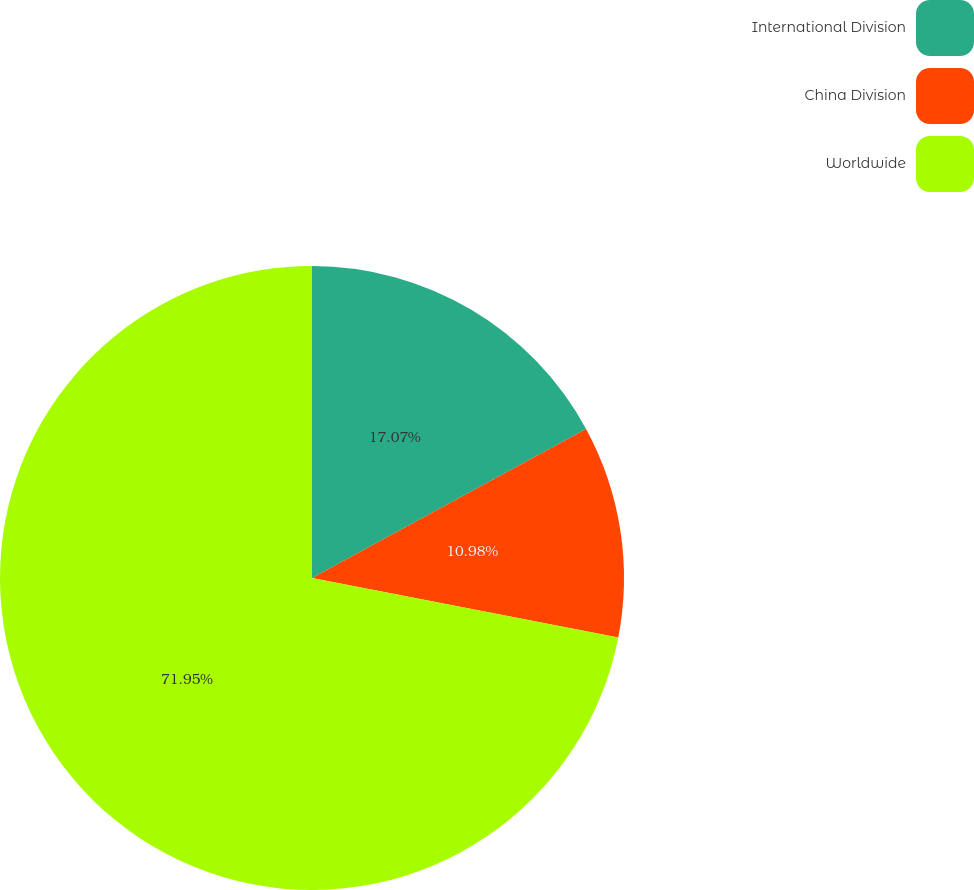Convert chart to OTSL. <chart><loc_0><loc_0><loc_500><loc_500><pie_chart><fcel>International Division<fcel>China Division<fcel>Worldwide<nl><fcel>17.07%<fcel>10.98%<fcel>71.95%<nl></chart> 